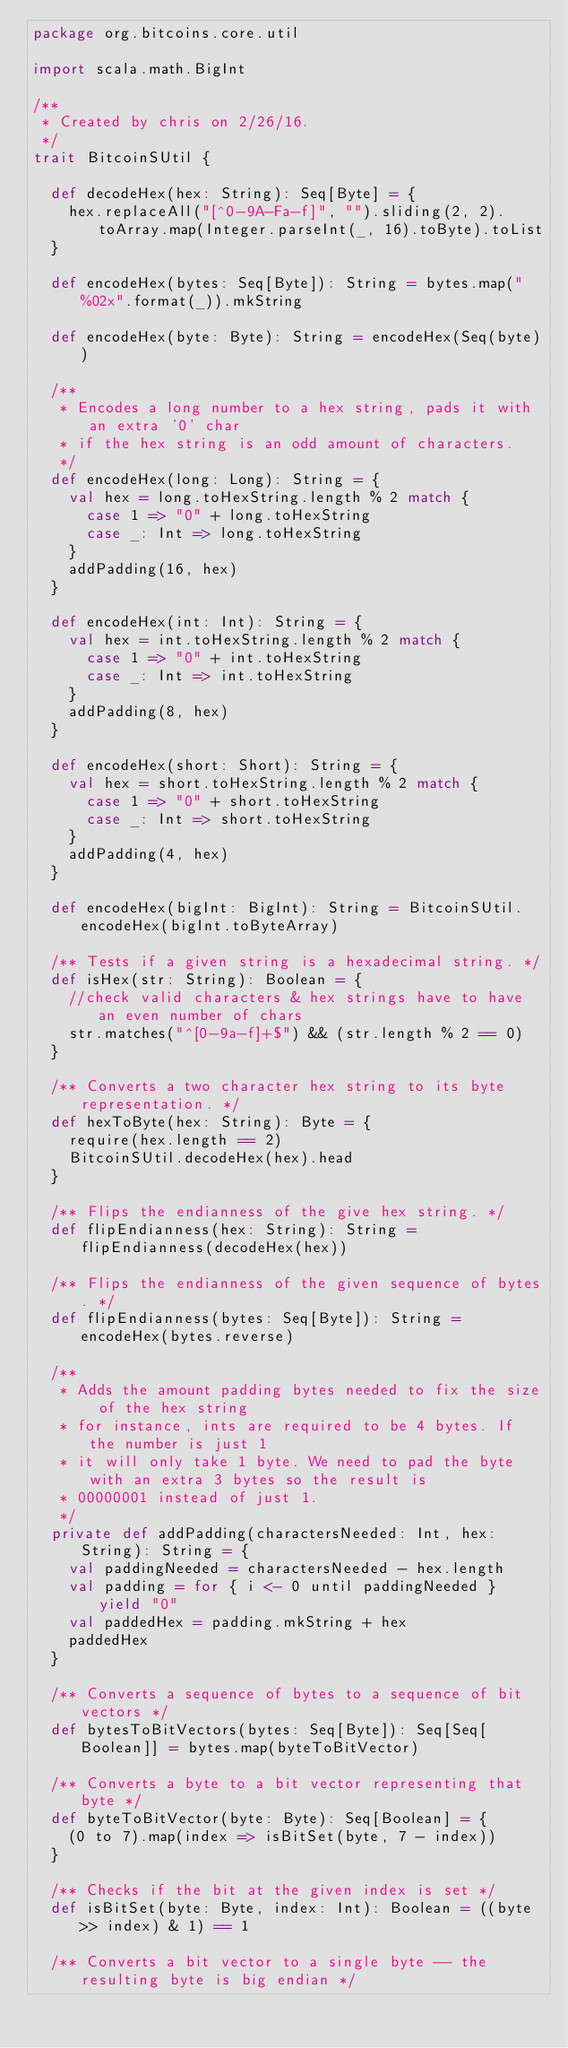<code> <loc_0><loc_0><loc_500><loc_500><_Scala_>package org.bitcoins.core.util

import scala.math.BigInt

/**
 * Created by chris on 2/26/16.
 */
trait BitcoinSUtil {

  def decodeHex(hex: String): Seq[Byte] = {
    hex.replaceAll("[^0-9A-Fa-f]", "").sliding(2, 2).toArray.map(Integer.parseInt(_, 16).toByte).toList
  }

  def encodeHex(bytes: Seq[Byte]): String = bytes.map("%02x".format(_)).mkString

  def encodeHex(byte: Byte): String = encodeHex(Seq(byte))

  /**
   * Encodes a long number to a hex string, pads it with an extra '0' char
   * if the hex string is an odd amount of characters.
   */
  def encodeHex(long: Long): String = {
    val hex = long.toHexString.length % 2 match {
      case 1 => "0" + long.toHexString
      case _: Int => long.toHexString
    }
    addPadding(16, hex)
  }

  def encodeHex(int: Int): String = {
    val hex = int.toHexString.length % 2 match {
      case 1 => "0" + int.toHexString
      case _: Int => int.toHexString
    }
    addPadding(8, hex)
  }

  def encodeHex(short: Short): String = {
    val hex = short.toHexString.length % 2 match {
      case 1 => "0" + short.toHexString
      case _: Int => short.toHexString
    }
    addPadding(4, hex)
  }

  def encodeHex(bigInt: BigInt): String = BitcoinSUtil.encodeHex(bigInt.toByteArray)

  /** Tests if a given string is a hexadecimal string. */
  def isHex(str: String): Boolean = {
    //check valid characters & hex strings have to have an even number of chars
    str.matches("^[0-9a-f]+$") && (str.length % 2 == 0)
  }

  /** Converts a two character hex string to its byte representation. */
  def hexToByte(hex: String): Byte = {
    require(hex.length == 2)
    BitcoinSUtil.decodeHex(hex).head
  }

  /** Flips the endianness of the give hex string. */
  def flipEndianness(hex: String): String = flipEndianness(decodeHex(hex))

  /** Flips the endianness of the given sequence of bytes. */
  def flipEndianness(bytes: Seq[Byte]): String = encodeHex(bytes.reverse)

  /**
   * Adds the amount padding bytes needed to fix the size of the hex string
   * for instance, ints are required to be 4 bytes. If the number is just 1
   * it will only take 1 byte. We need to pad the byte with an extra 3 bytes so the result is
   * 00000001 instead of just 1.
   */
  private def addPadding(charactersNeeded: Int, hex: String): String = {
    val paddingNeeded = charactersNeeded - hex.length
    val padding = for { i <- 0 until paddingNeeded } yield "0"
    val paddedHex = padding.mkString + hex
    paddedHex
  }

  /** Converts a sequence of bytes to a sequence of bit vectors */
  def bytesToBitVectors(bytes: Seq[Byte]): Seq[Seq[Boolean]] = bytes.map(byteToBitVector)

  /** Converts a byte to a bit vector representing that byte */
  def byteToBitVector(byte: Byte): Seq[Boolean] = {
    (0 to 7).map(index => isBitSet(byte, 7 - index))
  }

  /** Checks if the bit at the given index is set */
  def isBitSet(byte: Byte, index: Int): Boolean = ((byte >> index) & 1) == 1

  /** Converts a bit vector to a single byte -- the resulting byte is big endian */</code> 